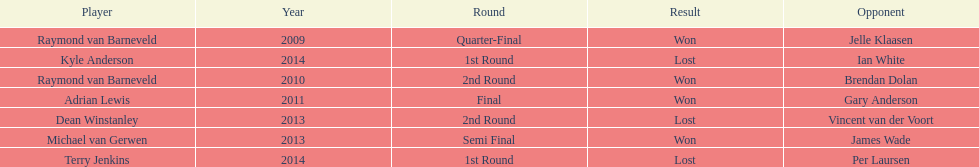Did terry jenkins or per laursen win in 2014? Per Laursen. 